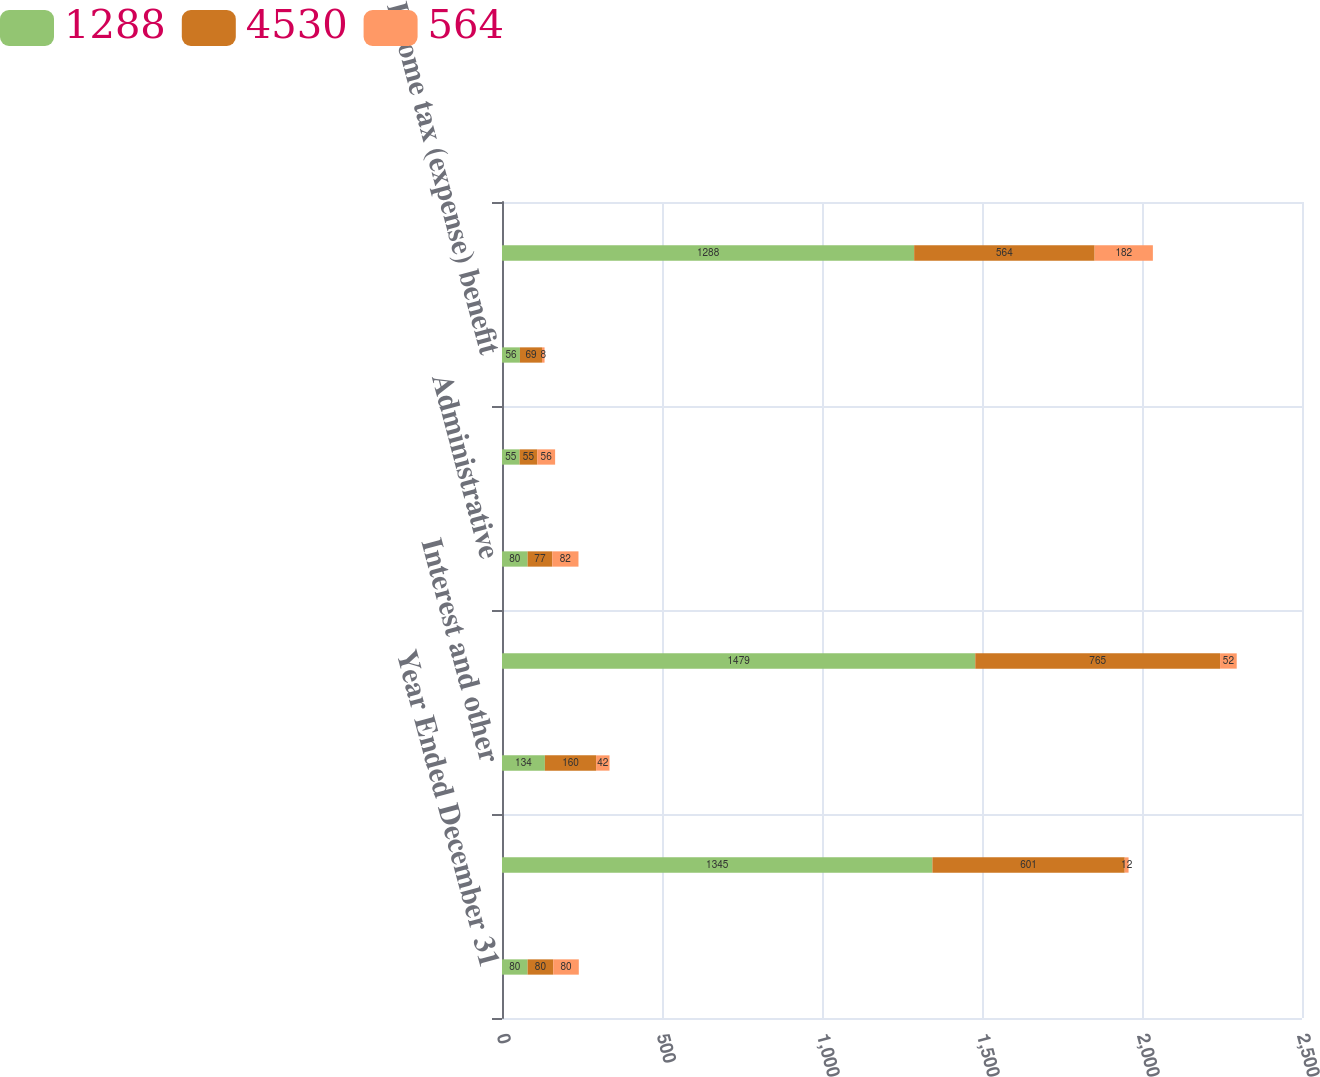<chart> <loc_0><loc_0><loc_500><loc_500><stacked_bar_chart><ecel><fcel>Year Ended December 31<fcel>Equity in income (loss) of<fcel>Interest and other<fcel>Total<fcel>Administrative<fcel>Interest<fcel>Income tax (expense) benefit<fcel>Income (loss) from continuing<nl><fcel>1288<fcel>80<fcel>1345<fcel>134<fcel>1479<fcel>80<fcel>55<fcel>56<fcel>1288<nl><fcel>4530<fcel>80<fcel>601<fcel>160<fcel>765<fcel>77<fcel>55<fcel>69<fcel>564<nl><fcel>564<fcel>80<fcel>12<fcel>42<fcel>52<fcel>82<fcel>56<fcel>8<fcel>182<nl></chart> 